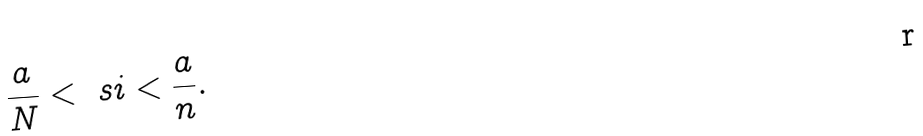<formula> <loc_0><loc_0><loc_500><loc_500>\frac { a } { N } < \ s i < \frac { a } { n } .</formula> 